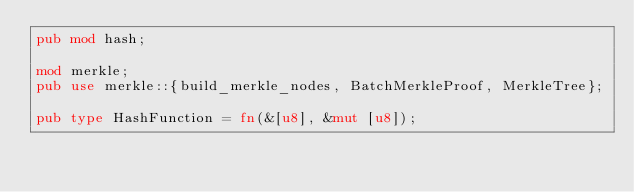Convert code to text. <code><loc_0><loc_0><loc_500><loc_500><_Rust_>pub mod hash;

mod merkle;
pub use merkle::{build_merkle_nodes, BatchMerkleProof, MerkleTree};

pub type HashFunction = fn(&[u8], &mut [u8]);
</code> 